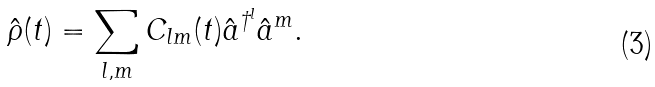Convert formula to latex. <formula><loc_0><loc_0><loc_500><loc_500>\hat { \rho } ( t ) = \sum _ { l , m } C _ { l m } ( t ) \hat { a } ^ { \dagger ^ { l } } \hat { a } ^ { m } .</formula> 